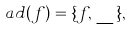Convert formula to latex. <formula><loc_0><loc_0><loc_500><loc_500>a d ( f ) = \{ f , \_ \} ,</formula> 